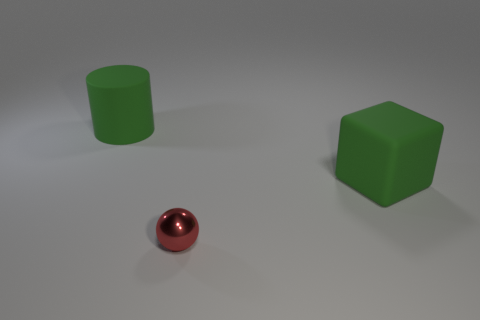Is the color of the large cylinder the same as the large rubber block?
Offer a terse response. Yes. What is the shape of the matte object that is the same color as the big matte cube?
Offer a very short reply. Cylinder. There is a thing that is behind the red sphere and on the left side of the green cube; what is its size?
Ensure brevity in your answer.  Large. How many other things are the same size as the red metallic thing?
Ensure brevity in your answer.  0. There is a matte object behind the green rubber thing that is right of the green rubber object that is behind the big cube; what color is it?
Your response must be concise. Green. There is a thing that is both to the left of the large green rubber cube and behind the tiny red thing; what is its shape?
Keep it short and to the point. Cylinder. How many other objects are there of the same shape as the red metallic thing?
Your answer should be compact. 0. There is a green rubber object on the right side of the green cylinder behind the big matte object that is right of the metallic thing; what shape is it?
Your answer should be compact. Cube. What number of things are green cylinders or objects that are in front of the large green rubber block?
Keep it short and to the point. 2. There is a object right of the small object; is it the same shape as the tiny red metallic object that is in front of the cylinder?
Provide a succinct answer. No. 